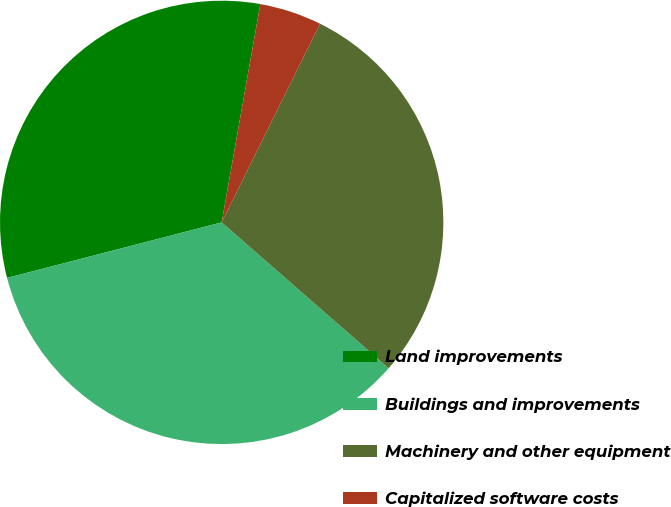Convert chart. <chart><loc_0><loc_0><loc_500><loc_500><pie_chart><fcel>Land improvements<fcel>Buildings and improvements<fcel>Machinery and other equipment<fcel>Capitalized software costs<nl><fcel>31.82%<fcel>34.54%<fcel>29.11%<fcel>4.53%<nl></chart> 